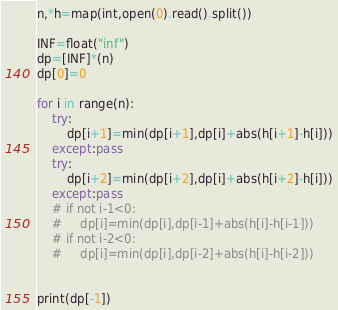Convert code to text. <code><loc_0><loc_0><loc_500><loc_500><_Python_>n,*h=map(int,open(0).read().split())

INF=float("inf")
dp=[INF]*(n)
dp[0]=0

for i in range(n):
    try:
        dp[i+1]=min(dp[i+1],dp[i]+abs(h[i+1]-h[i]))
    except:pass
    try:
        dp[i+2]=min(dp[i+2],dp[i]+abs(h[i+2]-h[i]))
    except:pass
    # if not i-1<0:
    #     dp[i]=min(dp[i],dp[i-1]+abs(h[i]-h[i-1]))
    # if not i-2<0:
    #     dp[i]=min(dp[i],dp[i-2]+abs(h[i]-h[i-2]))


print(dp[-1])</code> 